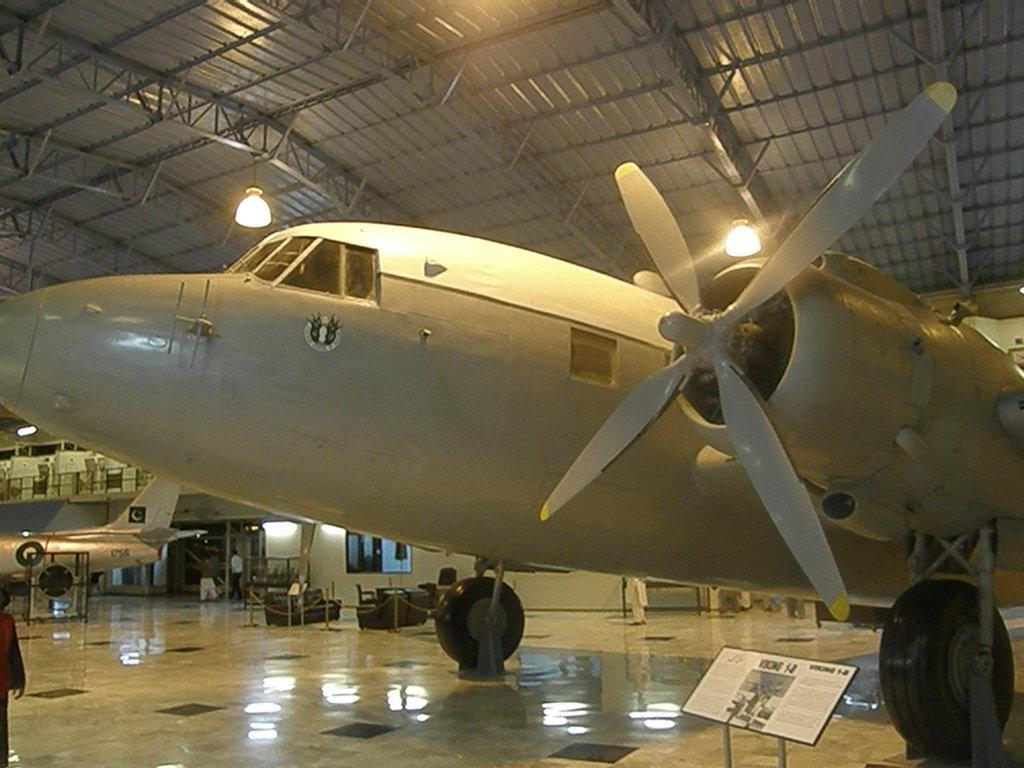In one or two sentences, can you explain what this image depicts? In this image we can see a plane on the floorboard on a stand and a person on the left side. In the background we can see few persons, objects on the floor, aeroplane, wall, railing, light hanging to the rods and roof. 